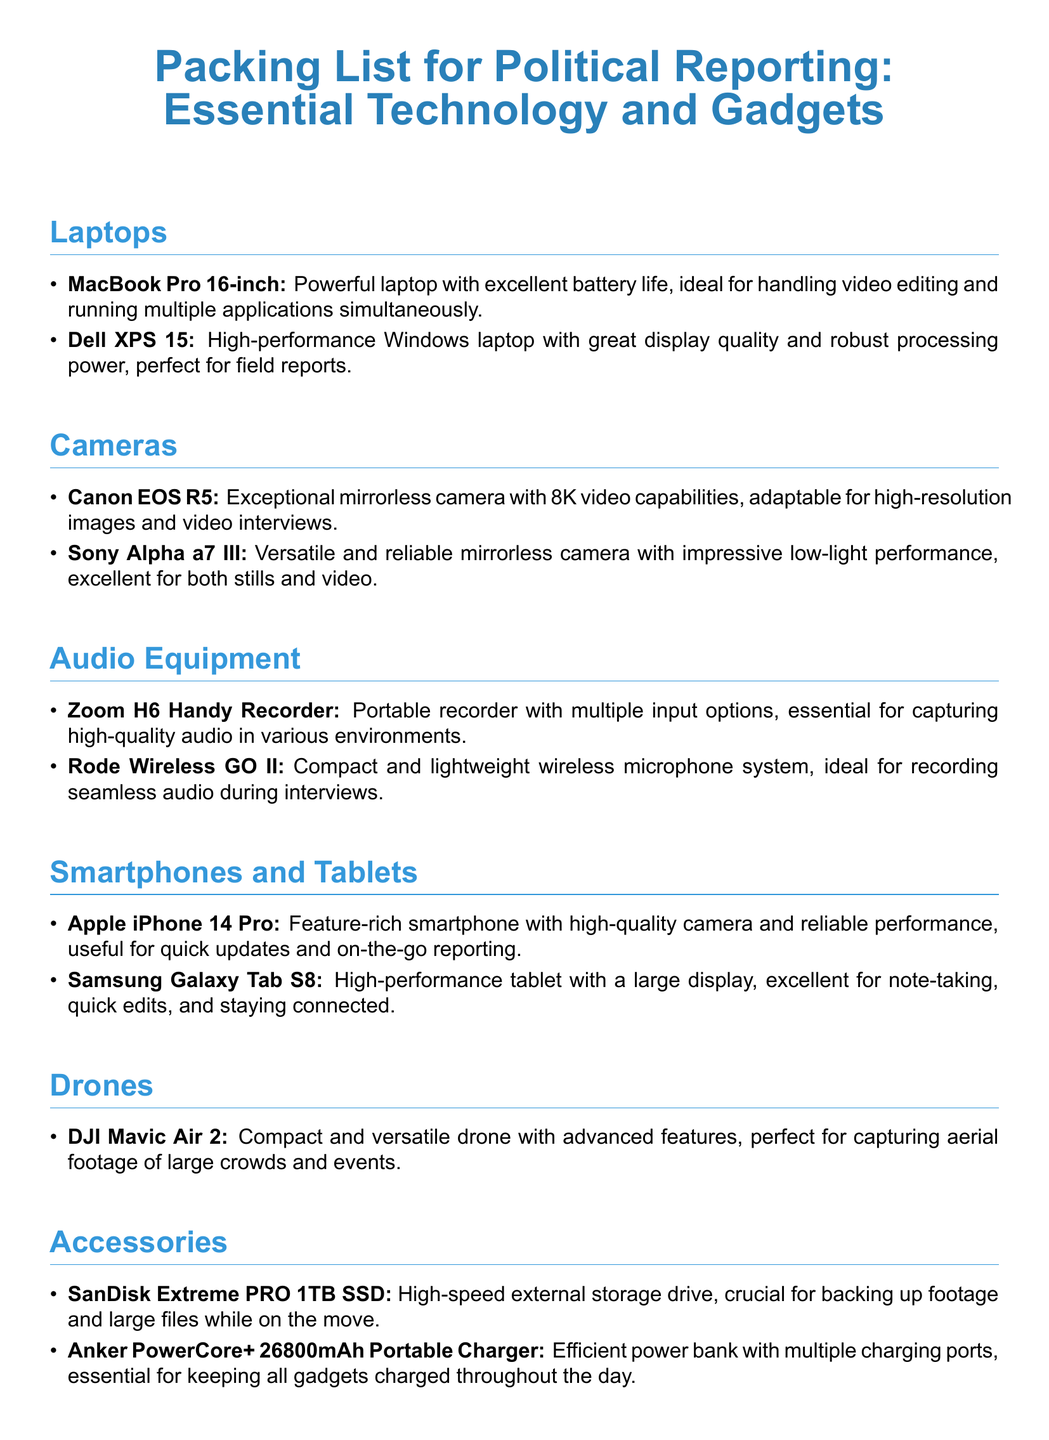What is the weight of the MacBook Pro? The document does not specify the weight of the MacBook Pro.
Answer: Not specified How many drones are listed? The document lists one drone under the Drones section.
Answer: 1 What type of audio recorder is included on the list? The document states a specific model of audio recorder, the Zoom H6 Handy Recorder.
Answer: Zoom H6 Handy Recorder Which tablet is recommended for political reporting? The document mentions only one tablet, which is the Samsung Galaxy Tab S8.
Answer: Samsung Galaxy Tab S8 What is the storage capacity of the SanDisk Extreme PRO SSD? The document shows the capacity of the mentioned external storage drive as 1TB.
Answer: 1TB What camera is noted for its low-light performance? The document specifies the Sony Alpha a7 III for its impressive low-light performance.
Answer: Sony Alpha a7 III Which software is essential for photo editing? The document points out Adobe Creative Cloud as the software for photo editing.
Answer: Adobe Creative Cloud What is the primary function of the Anker PowerCore+? The essence of the Anker PowerCore+ as stated is to efficiently charge gadgets.
Answer: Charging gadgets What type of camera is the Canon EOS R5? The document describes the Canon EOS R5 as a mirrorless camera.
Answer: Mirrorless camera What kind of smartphone is the Apple iPhone 14 Pro? The document identifies the Apple iPhone 14 Pro as a feature-rich smartphone.
Answer: Feature-rich smartphone 